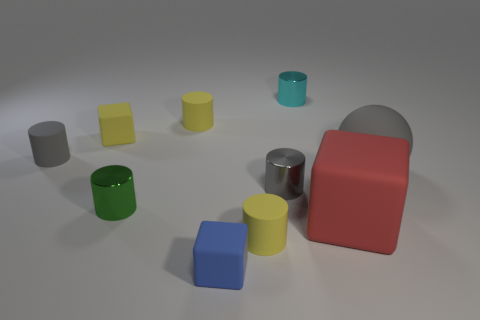What could these objects represent in a thematic analysis? These objects could represent diversity and unity in their assorted shapes and colors, signifying how different elements can coexist harmoniously. They might also symbolize building blocks, the fundamental components required to create or construct more complex systems or ideas. 